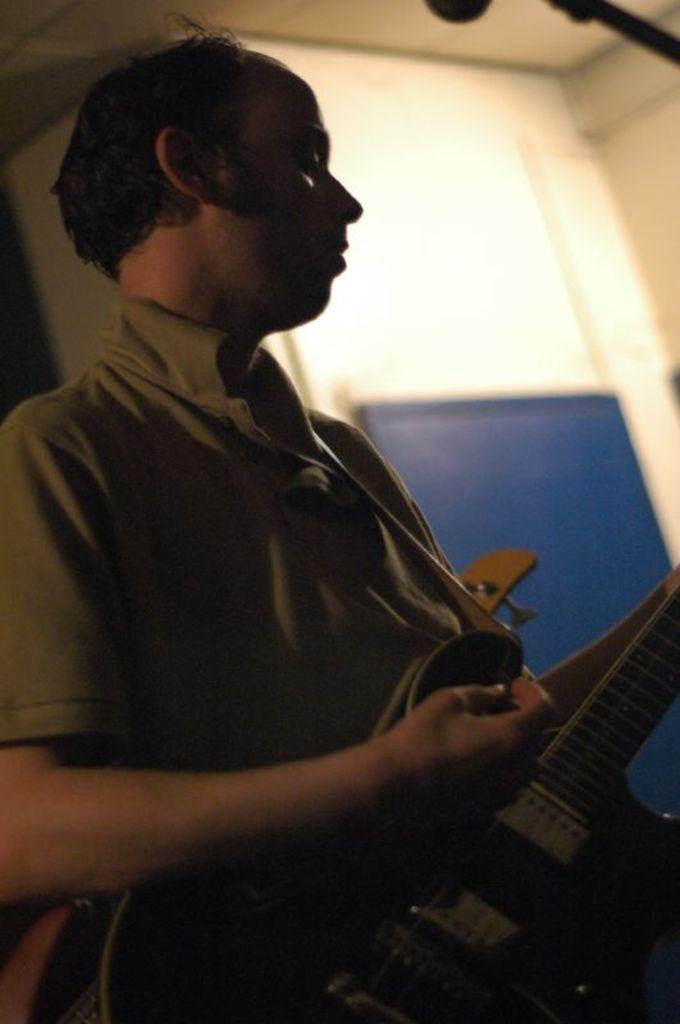Who is the main subject in the image? There is a man in the center of the image. What is the man holding in the image? The man is holding a guitar. What can be seen in the background of the image? There is a wall and a board in the background of the image. What type of thread is being used to play the guitar in the image? There is no thread being used to play the guitar in the image; the man is holding the guitar with his hands. 